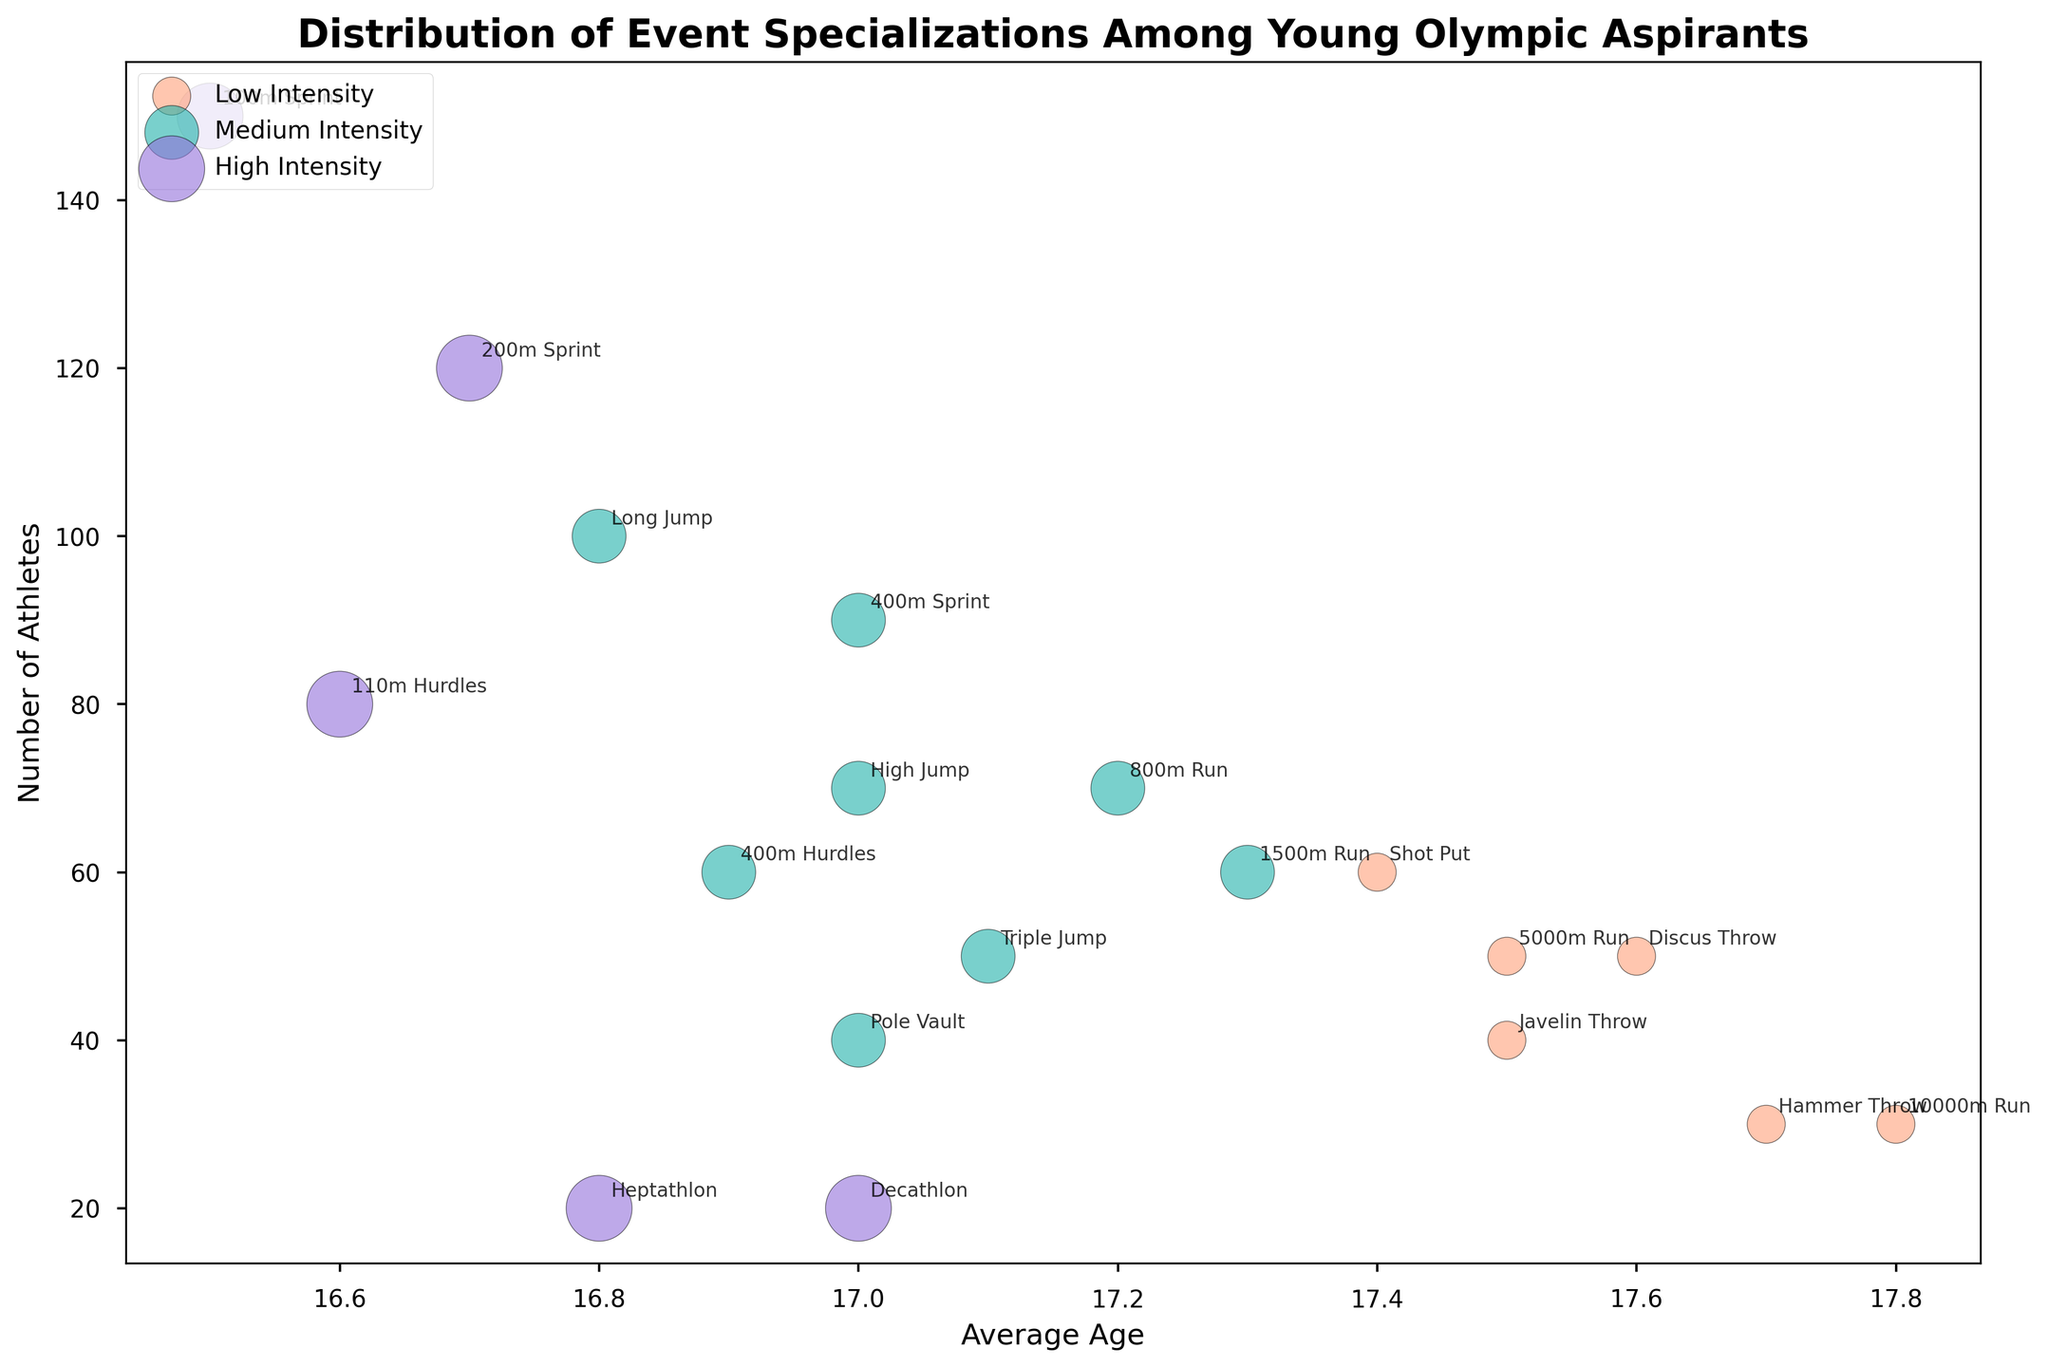Which event has the highest number of athletes? The '100m Sprint' bubble is the largest and positioned at the top indicating it has the highest number of athletes.
Answer: 100m Sprint What is the average age for the athletes specializing in the 1500m Run? Look for the '1500m Run' label and check its position on the x-axis representing the average age.
Answer: 17.3 How many athletes specialize in events with a high-intensity level? Identify all events labeled as high intensity and sum their numbers: 150 (100m Sprint) + 120 (200m Sprint) + 80 (110m Hurdles) + 20 (Decathlon) + 20 (Heptathlon).
Answer: 390 Which event has the least number of athletes? Among all the bubbles, the smallest one corresponds to the 'Decathlon' and 'Heptathlon' both having an equal number of athletes.
Answer: Decathlon or Heptathlon Compare the number of athletes in the 400m Sprint and Long Jump events. Which event has fewer athletes? Compare the bubble sizes of '400m Sprint' and 'Long Jump'. The '400m Sprint' has 90 athletes while 'Long Jump' has 100.
Answer: 400m Sprint What's the intensity level of the event with athletes of the youngest average age? Locate the bubble with the lowest average age on the x-axis. '100m Sprint' has the youngest average age of 16.5 and is labeled as high intensity.
Answer: High Which event has an average age closest to 17 years and what is its intensity level? Identify the bubble positioned nearest to 17 on the x-axis. '400m Sprint' and 'High Jump' both have exactly 17 and are medium intensity.
Answer: Medium How many events are categorized under medium intensity? Count the number of different events positioned with 'Medium' intensity color.
Answer: 9 What's the difference in the number of athletes between the 110m Hurdles and Pole Vault? Subtract the number of athletes in 'Pole Vault' (40) from the number of athletes in '110m Hurdles' (80).
Answer: 40 Are there more athletes participating in medium or low-intensity events? Sum the total number of athletes for medium and low-intensity levels and compare. Medium: 90 (400m Sprint) + 70 (800m Run) + 60 (1500m Run) + 60 (400m Hurdles) + 100 (Long Jump) + 50 (Triple Jump) + 70 (High Jump) + 40 (Pole Vault) + 50. Low: 50 (5000m Run) + 30 (10000m Run) + 60 (Shot Put) + 50 (Discus Throw) + 30 (Hammer Throw) + 40 (Javelin Throw).
Answer: Medium 